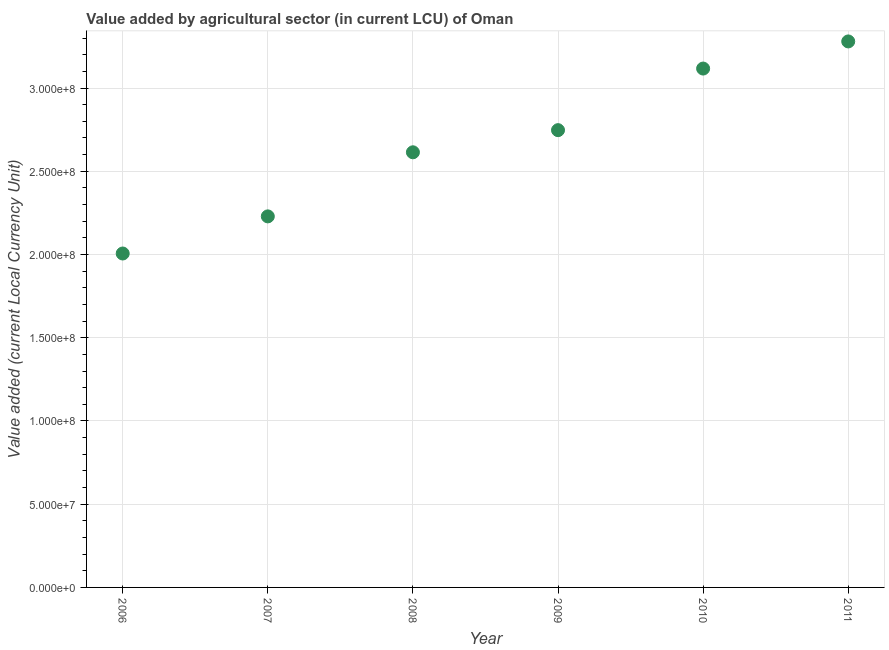What is the value added by agriculture sector in 2007?
Provide a succinct answer. 2.23e+08. Across all years, what is the maximum value added by agriculture sector?
Make the answer very short. 3.28e+08. Across all years, what is the minimum value added by agriculture sector?
Provide a succinct answer. 2.01e+08. In which year was the value added by agriculture sector maximum?
Provide a succinct answer. 2011. In which year was the value added by agriculture sector minimum?
Ensure brevity in your answer.  2006. What is the sum of the value added by agriculture sector?
Ensure brevity in your answer.  1.60e+09. What is the difference between the value added by agriculture sector in 2006 and 2010?
Your response must be concise. -1.11e+08. What is the average value added by agriculture sector per year?
Provide a short and direct response. 2.67e+08. What is the median value added by agriculture sector?
Provide a short and direct response. 2.68e+08. In how many years, is the value added by agriculture sector greater than 50000000 LCU?
Give a very brief answer. 6. What is the ratio of the value added by agriculture sector in 2006 to that in 2010?
Provide a succinct answer. 0.64. Is the value added by agriculture sector in 2008 less than that in 2011?
Offer a very short reply. Yes. What is the difference between the highest and the second highest value added by agriculture sector?
Your answer should be very brief. 1.63e+07. Is the sum of the value added by agriculture sector in 2008 and 2010 greater than the maximum value added by agriculture sector across all years?
Provide a succinct answer. Yes. What is the difference between the highest and the lowest value added by agriculture sector?
Your answer should be very brief. 1.27e+08. In how many years, is the value added by agriculture sector greater than the average value added by agriculture sector taken over all years?
Your answer should be compact. 3. How many dotlines are there?
Give a very brief answer. 1. How many years are there in the graph?
Your answer should be compact. 6. Are the values on the major ticks of Y-axis written in scientific E-notation?
Keep it short and to the point. Yes. Does the graph contain any zero values?
Offer a terse response. No. Does the graph contain grids?
Keep it short and to the point. Yes. What is the title of the graph?
Keep it short and to the point. Value added by agricultural sector (in current LCU) of Oman. What is the label or title of the X-axis?
Provide a succinct answer. Year. What is the label or title of the Y-axis?
Your answer should be very brief. Value added (current Local Currency Unit). What is the Value added (current Local Currency Unit) in 2006?
Ensure brevity in your answer.  2.01e+08. What is the Value added (current Local Currency Unit) in 2007?
Offer a very short reply. 2.23e+08. What is the Value added (current Local Currency Unit) in 2008?
Make the answer very short. 2.61e+08. What is the Value added (current Local Currency Unit) in 2009?
Your answer should be compact. 2.75e+08. What is the Value added (current Local Currency Unit) in 2010?
Your answer should be very brief. 3.12e+08. What is the Value added (current Local Currency Unit) in 2011?
Ensure brevity in your answer.  3.28e+08. What is the difference between the Value added (current Local Currency Unit) in 2006 and 2007?
Your answer should be very brief. -2.23e+07. What is the difference between the Value added (current Local Currency Unit) in 2006 and 2008?
Give a very brief answer. -6.08e+07. What is the difference between the Value added (current Local Currency Unit) in 2006 and 2009?
Your answer should be compact. -7.41e+07. What is the difference between the Value added (current Local Currency Unit) in 2006 and 2010?
Offer a terse response. -1.11e+08. What is the difference between the Value added (current Local Currency Unit) in 2006 and 2011?
Your response must be concise. -1.27e+08. What is the difference between the Value added (current Local Currency Unit) in 2007 and 2008?
Provide a short and direct response. -3.85e+07. What is the difference between the Value added (current Local Currency Unit) in 2007 and 2009?
Give a very brief answer. -5.18e+07. What is the difference between the Value added (current Local Currency Unit) in 2007 and 2010?
Give a very brief answer. -8.88e+07. What is the difference between the Value added (current Local Currency Unit) in 2007 and 2011?
Your answer should be compact. -1.05e+08. What is the difference between the Value added (current Local Currency Unit) in 2008 and 2009?
Your answer should be very brief. -1.33e+07. What is the difference between the Value added (current Local Currency Unit) in 2008 and 2010?
Make the answer very short. -5.03e+07. What is the difference between the Value added (current Local Currency Unit) in 2008 and 2011?
Ensure brevity in your answer.  -6.66e+07. What is the difference between the Value added (current Local Currency Unit) in 2009 and 2010?
Provide a succinct answer. -3.70e+07. What is the difference between the Value added (current Local Currency Unit) in 2009 and 2011?
Give a very brief answer. -5.33e+07. What is the difference between the Value added (current Local Currency Unit) in 2010 and 2011?
Your answer should be compact. -1.63e+07. What is the ratio of the Value added (current Local Currency Unit) in 2006 to that in 2008?
Make the answer very short. 0.77. What is the ratio of the Value added (current Local Currency Unit) in 2006 to that in 2009?
Your answer should be compact. 0.73. What is the ratio of the Value added (current Local Currency Unit) in 2006 to that in 2010?
Provide a succinct answer. 0.64. What is the ratio of the Value added (current Local Currency Unit) in 2006 to that in 2011?
Your answer should be very brief. 0.61. What is the ratio of the Value added (current Local Currency Unit) in 2007 to that in 2008?
Offer a terse response. 0.85. What is the ratio of the Value added (current Local Currency Unit) in 2007 to that in 2009?
Give a very brief answer. 0.81. What is the ratio of the Value added (current Local Currency Unit) in 2007 to that in 2010?
Offer a terse response. 0.71. What is the ratio of the Value added (current Local Currency Unit) in 2007 to that in 2011?
Ensure brevity in your answer.  0.68. What is the ratio of the Value added (current Local Currency Unit) in 2008 to that in 2009?
Provide a succinct answer. 0.95. What is the ratio of the Value added (current Local Currency Unit) in 2008 to that in 2010?
Offer a very short reply. 0.84. What is the ratio of the Value added (current Local Currency Unit) in 2008 to that in 2011?
Your response must be concise. 0.8. What is the ratio of the Value added (current Local Currency Unit) in 2009 to that in 2010?
Give a very brief answer. 0.88. What is the ratio of the Value added (current Local Currency Unit) in 2009 to that in 2011?
Keep it short and to the point. 0.84. 